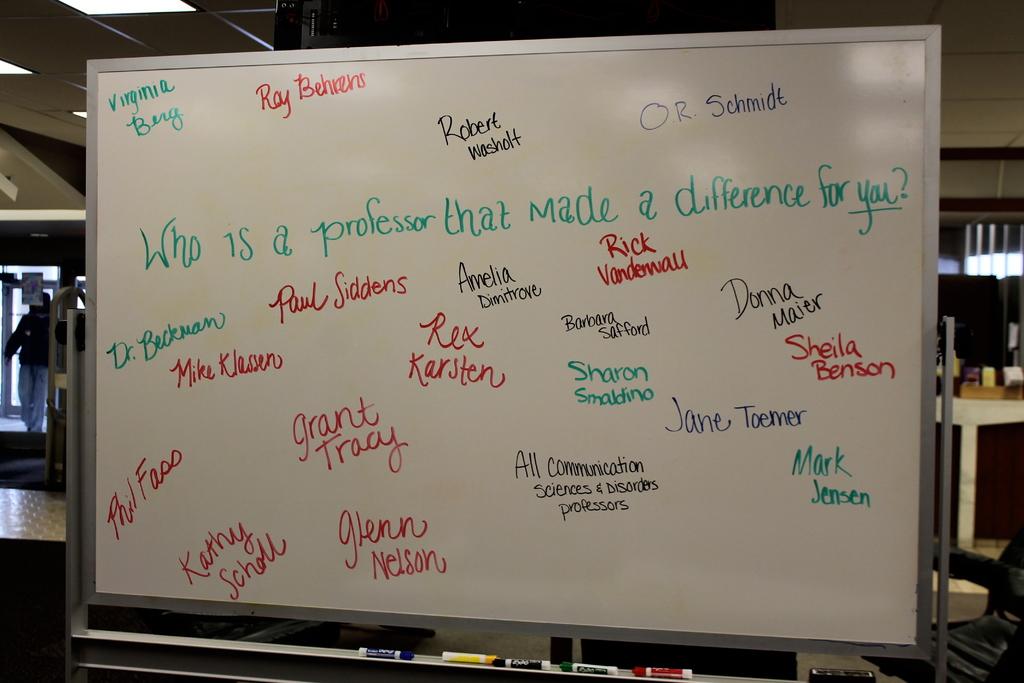What is the name of the doctor on the white board?
Your answer should be compact. Beckman. What is ray's last name?
Your answer should be compact. Behrens. 